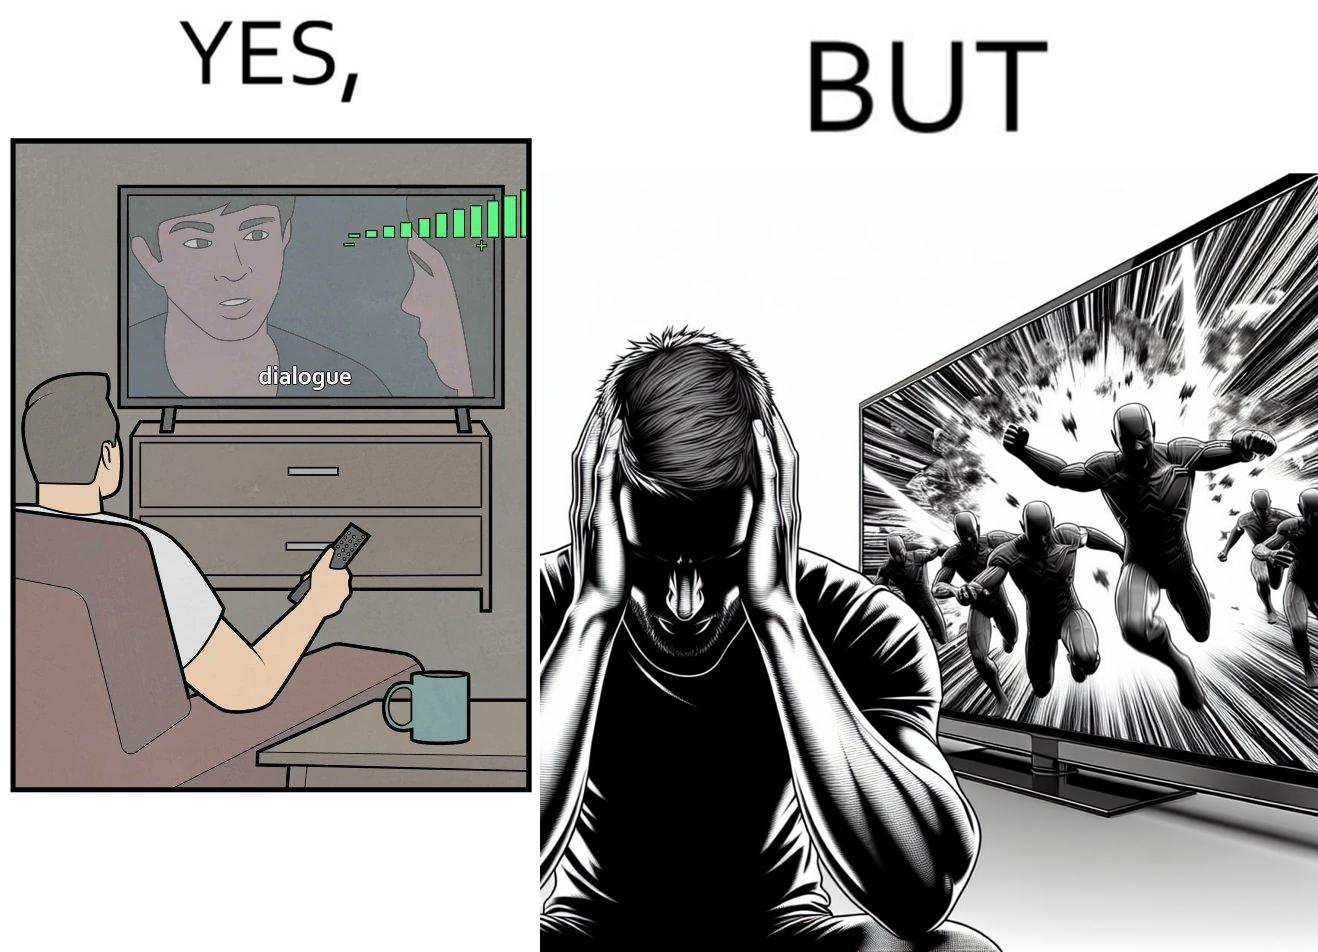Why is this image considered satirical? The action scenes of the movies or TV programs are mostly low in sound and people aren't able to hear them properly but in the action scenes due to the background music and other noise the sound becomes unbearable to some peoples 